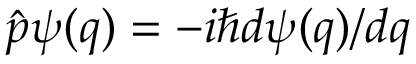Convert formula to latex. <formula><loc_0><loc_0><loc_500><loc_500>{ \hat { p } } \psi ( q ) = - i \hbar { d } \psi ( q ) / d q</formula> 